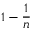Convert formula to latex. <formula><loc_0><loc_0><loc_500><loc_500>1 - { \frac { 1 } { n } }</formula> 